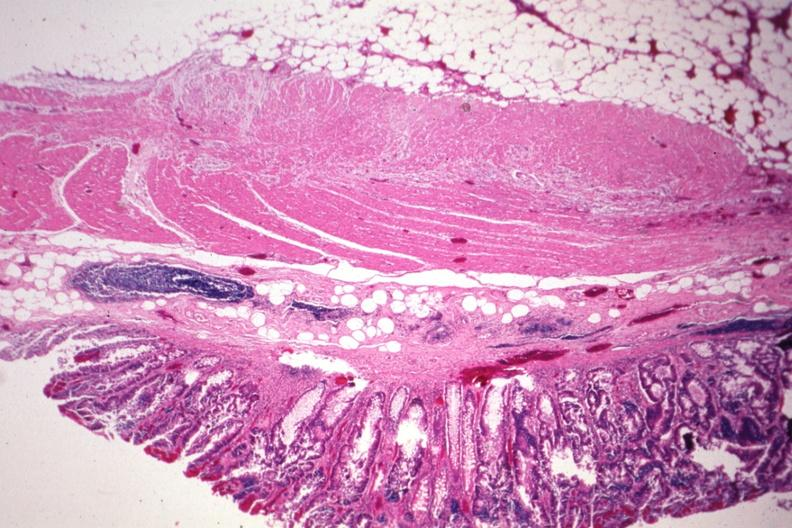what is present?
Answer the question using a single word or phrase. Colon 